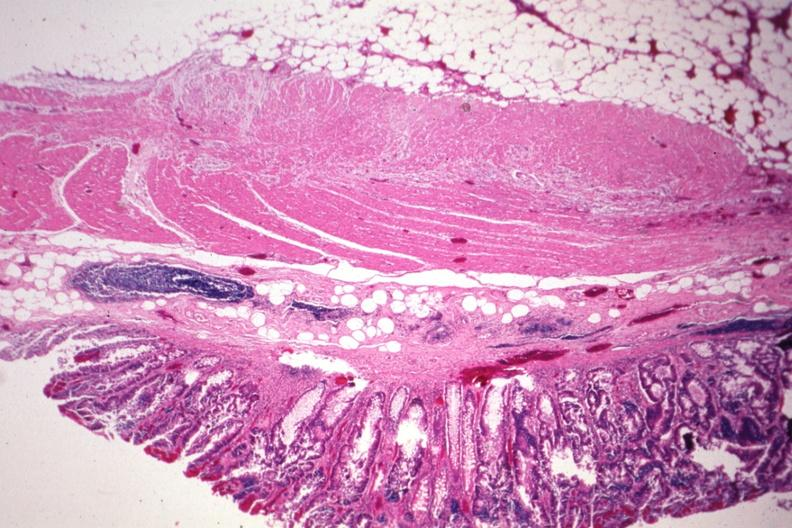what is present?
Answer the question using a single word or phrase. Colon 